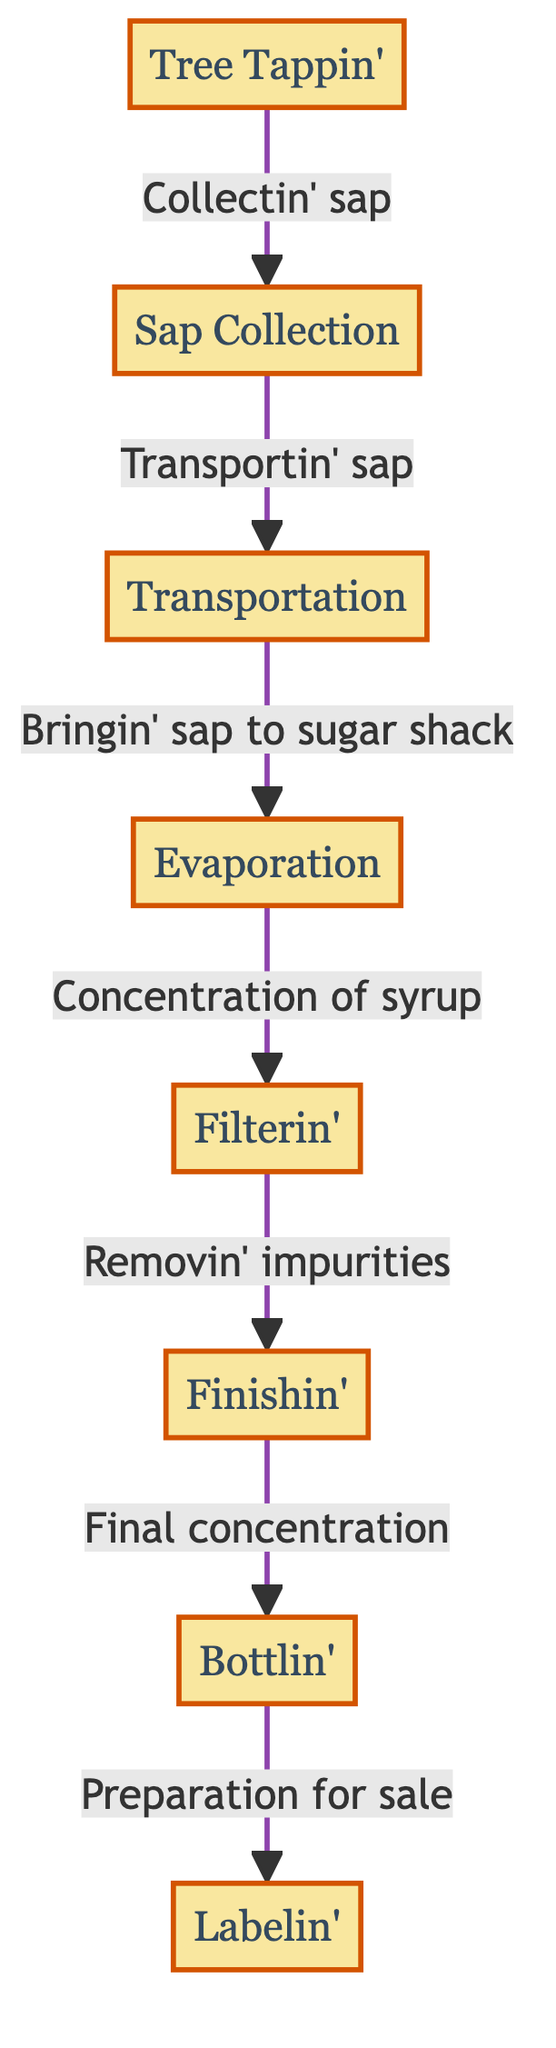What is the first step in the maple syrup production process? The diagram begins with the node labeled "Tree Tappin'." This is the starting point of the production process where the sap is collected from maple trees.
Answer: Tree Tappin' How many steps are there in the maple syrup production process? Counting the nodes in the diagram, there are a total of seven distinct steps: Tree Tappin', Sap Collection, Transportation, Evaporation, Filtering, Finishing, and Bottling.
Answer: 7 What flows from Sap Collection to Transportation? The arrow connecting these two nodes indicates that the sap collected from the trees is then transported, which clarifies the process flow from collection to transport.
Answer: Transportin' sap Which step involves removing impurities from the syrup? The specific step in the diagram that addresses the removal of impurities is labeled "Filterin'." This highlights that filtering occurs after evaporation to ensure the syrup's quality.
Answer: Filterin' What is the final step before the syrup is prepared for sale? According to the diagram, the step that comes just before the syrup's preparation for sale is "Bottlin'." This denotes that the syrup is put into bottles prior to being packaged for market.
Answer: Bottlin' What is the relationship between Evaporation and Filtering in the process? The relationship shown in the diagram indicates a sequential flow; after the Evaporation step, syrup proceeds to the Filtering step, which means filtering takes place immediately after evaporation to enhance syrup quality.
Answer: Concentration of syrup What node comes just before Bottling in the process? The diagram clearly indicates that the step labeled "Finishin'" precedes "Bottlin'," which suggests that final preparations and quality checks occur before the syrup is packaged in bottles.
Answer: Finishin' How does sap get to the sugar shack in the process? The diagram explicitly states that sap collected is transported to the sugar shack as shown in the flow between the Sap Collection node and the Evaporation step, indicating this as part of the production workflow.
Answer: Bringin' sap to sugar shack 